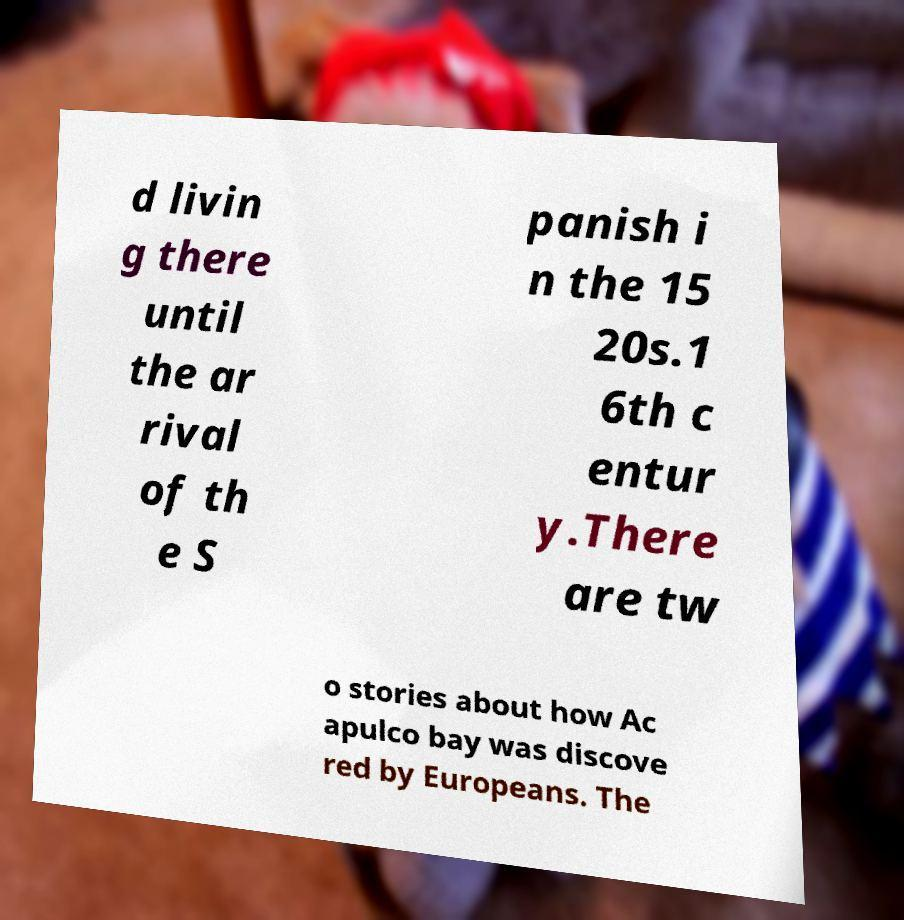For documentation purposes, I need the text within this image transcribed. Could you provide that? d livin g there until the ar rival of th e S panish i n the 15 20s.1 6th c entur y.There are tw o stories about how Ac apulco bay was discove red by Europeans. The 